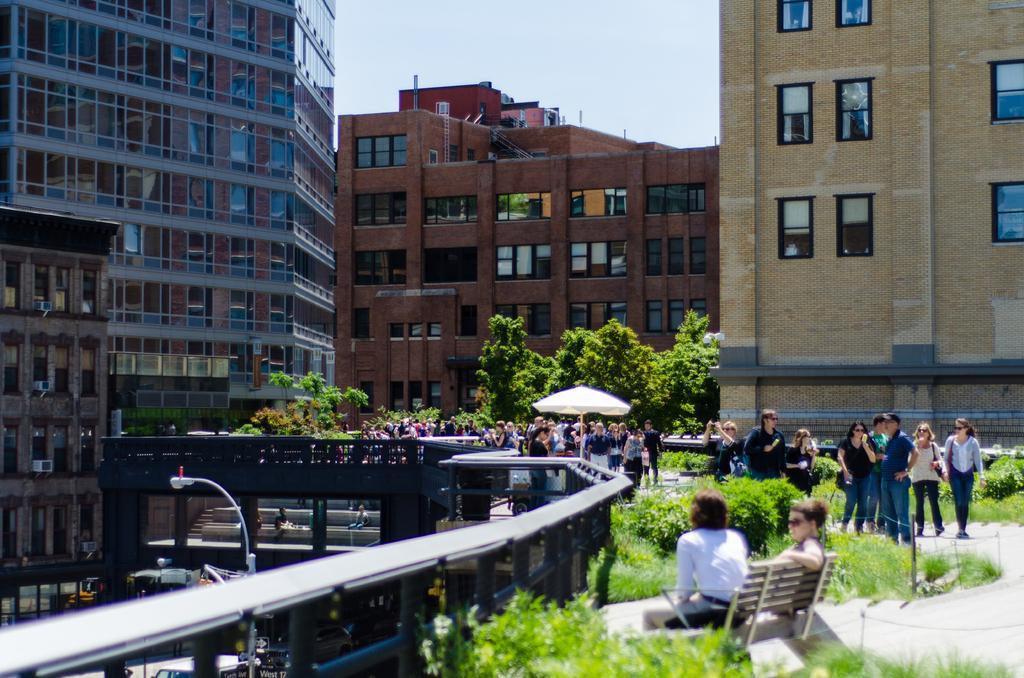Please provide a concise description of this image. In this image at the bottom there is a man, he wears a shirt, trouser and there is a woman, they are sitting on the bench. At the bottom there are plants, grass, people, umbrella, trees, street lights, staircase. At the top there are buildings, windows, sky. 